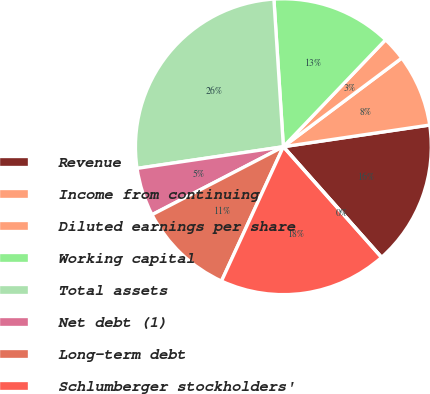Convert chart. <chart><loc_0><loc_0><loc_500><loc_500><pie_chart><fcel>Revenue<fcel>Income from continuing<fcel>Diluted earnings per share<fcel>Working capital<fcel>Total assets<fcel>Net debt (1)<fcel>Long-term debt<fcel>Schlumberger stockholders'<fcel>Cash dividends declared per<nl><fcel>15.79%<fcel>7.89%<fcel>2.63%<fcel>13.16%<fcel>26.32%<fcel>5.26%<fcel>10.53%<fcel>18.42%<fcel>0.0%<nl></chart> 